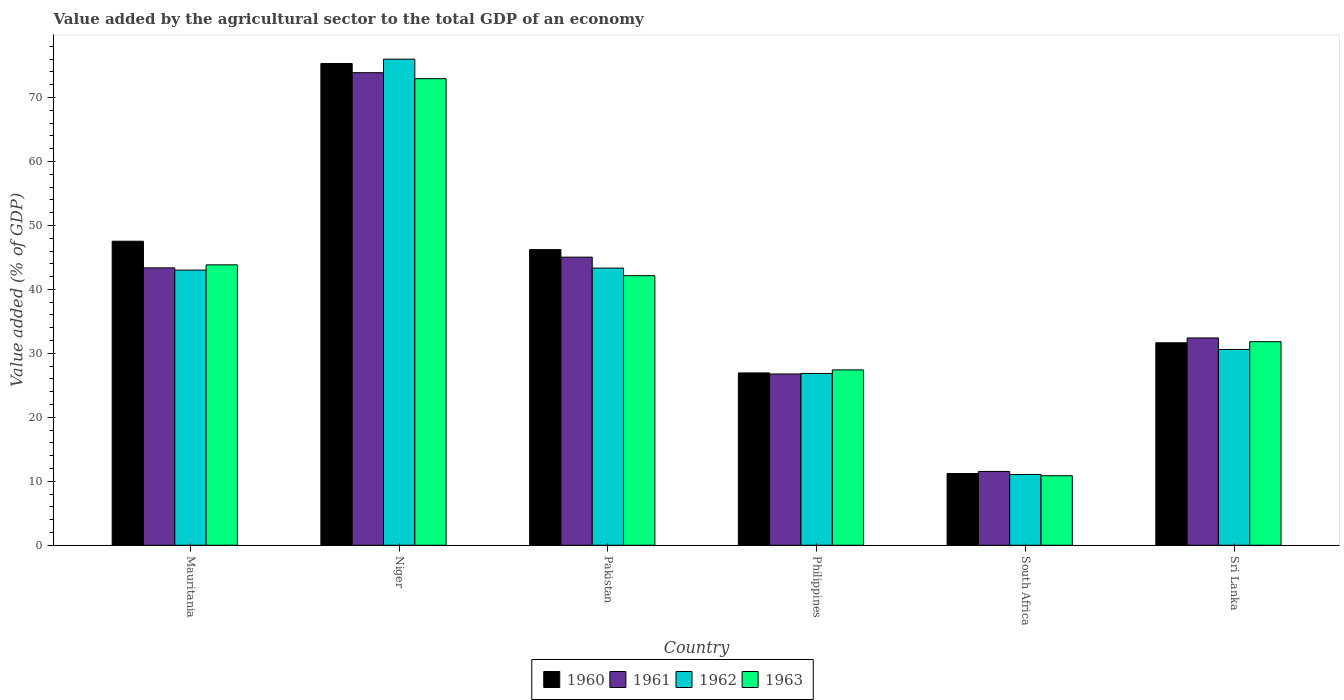Are the number of bars per tick equal to the number of legend labels?
Offer a terse response. Yes. Are the number of bars on each tick of the X-axis equal?
Provide a short and direct response. Yes. How many bars are there on the 3rd tick from the left?
Your answer should be very brief. 4. How many bars are there on the 1st tick from the right?
Your answer should be compact. 4. What is the label of the 5th group of bars from the left?
Offer a terse response. South Africa. In how many cases, is the number of bars for a given country not equal to the number of legend labels?
Keep it short and to the point. 0. What is the value added by the agricultural sector to the total GDP in 1963 in Pakistan?
Provide a short and direct response. 42.15. Across all countries, what is the maximum value added by the agricultural sector to the total GDP in 1962?
Make the answer very short. 76. Across all countries, what is the minimum value added by the agricultural sector to the total GDP in 1961?
Your answer should be compact. 11.54. In which country was the value added by the agricultural sector to the total GDP in 1961 maximum?
Provide a short and direct response. Niger. In which country was the value added by the agricultural sector to the total GDP in 1960 minimum?
Make the answer very short. South Africa. What is the total value added by the agricultural sector to the total GDP in 1960 in the graph?
Keep it short and to the point. 238.89. What is the difference between the value added by the agricultural sector to the total GDP in 1963 in Mauritania and that in Pakistan?
Keep it short and to the point. 1.69. What is the difference between the value added by the agricultural sector to the total GDP in 1960 in Mauritania and the value added by the agricultural sector to the total GDP in 1961 in Pakistan?
Your answer should be compact. 2.49. What is the average value added by the agricultural sector to the total GDP in 1961 per country?
Your answer should be very brief. 38.84. What is the difference between the value added by the agricultural sector to the total GDP of/in 1961 and value added by the agricultural sector to the total GDP of/in 1962 in Philippines?
Make the answer very short. -0.08. What is the ratio of the value added by the agricultural sector to the total GDP in 1962 in Mauritania to that in Sri Lanka?
Provide a short and direct response. 1.41. Is the difference between the value added by the agricultural sector to the total GDP in 1961 in Pakistan and Sri Lanka greater than the difference between the value added by the agricultural sector to the total GDP in 1962 in Pakistan and Sri Lanka?
Offer a very short reply. No. What is the difference between the highest and the second highest value added by the agricultural sector to the total GDP in 1961?
Your answer should be compact. 30.52. What is the difference between the highest and the lowest value added by the agricultural sector to the total GDP in 1961?
Offer a terse response. 62.35. Is it the case that in every country, the sum of the value added by the agricultural sector to the total GDP in 1963 and value added by the agricultural sector to the total GDP in 1962 is greater than the sum of value added by the agricultural sector to the total GDP in 1960 and value added by the agricultural sector to the total GDP in 1961?
Make the answer very short. No. What does the 2nd bar from the left in Philippines represents?
Offer a terse response. 1961. What does the 3rd bar from the right in Sri Lanka represents?
Ensure brevity in your answer.  1961. Is it the case that in every country, the sum of the value added by the agricultural sector to the total GDP in 1963 and value added by the agricultural sector to the total GDP in 1962 is greater than the value added by the agricultural sector to the total GDP in 1960?
Your response must be concise. Yes. Are all the bars in the graph horizontal?
Your answer should be compact. No. How many countries are there in the graph?
Offer a very short reply. 6. Does the graph contain any zero values?
Your answer should be compact. No. Does the graph contain grids?
Your response must be concise. No. Where does the legend appear in the graph?
Make the answer very short. Bottom center. How many legend labels are there?
Offer a terse response. 4. What is the title of the graph?
Your response must be concise. Value added by the agricultural sector to the total GDP of an economy. Does "1979" appear as one of the legend labels in the graph?
Offer a terse response. No. What is the label or title of the X-axis?
Your answer should be very brief. Country. What is the label or title of the Y-axis?
Provide a short and direct response. Value added (% of GDP). What is the Value added (% of GDP) in 1960 in Mauritania?
Your response must be concise. 47.53. What is the Value added (% of GDP) in 1961 in Mauritania?
Provide a succinct answer. 43.37. What is the Value added (% of GDP) in 1962 in Mauritania?
Keep it short and to the point. 43.02. What is the Value added (% of GDP) in 1963 in Mauritania?
Your answer should be compact. 43.84. What is the Value added (% of GDP) of 1960 in Niger?
Ensure brevity in your answer.  75.32. What is the Value added (% of GDP) of 1961 in Niger?
Make the answer very short. 73.89. What is the Value added (% of GDP) of 1962 in Niger?
Ensure brevity in your answer.  76. What is the Value added (% of GDP) in 1963 in Niger?
Keep it short and to the point. 72.95. What is the Value added (% of GDP) in 1960 in Pakistan?
Your answer should be compact. 46.22. What is the Value added (% of GDP) in 1961 in Pakistan?
Your answer should be compact. 45.04. What is the Value added (% of GDP) in 1962 in Pakistan?
Ensure brevity in your answer.  43.33. What is the Value added (% of GDP) in 1963 in Pakistan?
Offer a terse response. 42.15. What is the Value added (% of GDP) in 1960 in Philippines?
Make the answer very short. 26.94. What is the Value added (% of GDP) of 1961 in Philippines?
Make the answer very short. 26.78. What is the Value added (% of GDP) of 1962 in Philippines?
Provide a short and direct response. 26.86. What is the Value added (% of GDP) of 1963 in Philippines?
Give a very brief answer. 27.41. What is the Value added (% of GDP) of 1960 in South Africa?
Your answer should be compact. 11.21. What is the Value added (% of GDP) in 1961 in South Africa?
Keep it short and to the point. 11.54. What is the Value added (% of GDP) of 1962 in South Africa?
Make the answer very short. 11.06. What is the Value added (% of GDP) in 1963 in South Africa?
Offer a very short reply. 10.87. What is the Value added (% of GDP) in 1960 in Sri Lanka?
Your answer should be very brief. 31.66. What is the Value added (% of GDP) in 1961 in Sri Lanka?
Your response must be concise. 32.41. What is the Value added (% of GDP) of 1962 in Sri Lanka?
Ensure brevity in your answer.  30.61. What is the Value added (% of GDP) of 1963 in Sri Lanka?
Ensure brevity in your answer.  31.83. Across all countries, what is the maximum Value added (% of GDP) in 1960?
Offer a terse response. 75.32. Across all countries, what is the maximum Value added (% of GDP) of 1961?
Offer a terse response. 73.89. Across all countries, what is the maximum Value added (% of GDP) in 1962?
Offer a terse response. 76. Across all countries, what is the maximum Value added (% of GDP) in 1963?
Provide a succinct answer. 72.95. Across all countries, what is the minimum Value added (% of GDP) of 1960?
Provide a short and direct response. 11.21. Across all countries, what is the minimum Value added (% of GDP) in 1961?
Ensure brevity in your answer.  11.54. Across all countries, what is the minimum Value added (% of GDP) in 1962?
Ensure brevity in your answer.  11.06. Across all countries, what is the minimum Value added (% of GDP) in 1963?
Your response must be concise. 10.87. What is the total Value added (% of GDP) of 1960 in the graph?
Provide a succinct answer. 238.89. What is the total Value added (% of GDP) of 1961 in the graph?
Provide a succinct answer. 233.02. What is the total Value added (% of GDP) of 1962 in the graph?
Make the answer very short. 230.88. What is the total Value added (% of GDP) of 1963 in the graph?
Provide a succinct answer. 229.04. What is the difference between the Value added (% of GDP) of 1960 in Mauritania and that in Niger?
Offer a very short reply. -27.79. What is the difference between the Value added (% of GDP) of 1961 in Mauritania and that in Niger?
Provide a short and direct response. -30.52. What is the difference between the Value added (% of GDP) of 1962 in Mauritania and that in Niger?
Provide a short and direct response. -32.98. What is the difference between the Value added (% of GDP) of 1963 in Mauritania and that in Niger?
Make the answer very short. -29.11. What is the difference between the Value added (% of GDP) in 1960 in Mauritania and that in Pakistan?
Keep it short and to the point. 1.31. What is the difference between the Value added (% of GDP) of 1961 in Mauritania and that in Pakistan?
Your response must be concise. -1.68. What is the difference between the Value added (% of GDP) in 1962 in Mauritania and that in Pakistan?
Make the answer very short. -0.31. What is the difference between the Value added (% of GDP) in 1963 in Mauritania and that in Pakistan?
Offer a very short reply. 1.69. What is the difference between the Value added (% of GDP) of 1960 in Mauritania and that in Philippines?
Provide a succinct answer. 20.59. What is the difference between the Value added (% of GDP) of 1961 in Mauritania and that in Philippines?
Provide a succinct answer. 16.59. What is the difference between the Value added (% of GDP) in 1962 in Mauritania and that in Philippines?
Your answer should be compact. 16.16. What is the difference between the Value added (% of GDP) in 1963 in Mauritania and that in Philippines?
Your answer should be very brief. 16.43. What is the difference between the Value added (% of GDP) of 1960 in Mauritania and that in South Africa?
Make the answer very short. 36.32. What is the difference between the Value added (% of GDP) of 1961 in Mauritania and that in South Africa?
Your answer should be very brief. 31.83. What is the difference between the Value added (% of GDP) in 1962 in Mauritania and that in South Africa?
Provide a short and direct response. 31.96. What is the difference between the Value added (% of GDP) in 1963 in Mauritania and that in South Africa?
Keep it short and to the point. 32.97. What is the difference between the Value added (% of GDP) of 1960 in Mauritania and that in Sri Lanka?
Provide a succinct answer. 15.88. What is the difference between the Value added (% of GDP) of 1961 in Mauritania and that in Sri Lanka?
Offer a terse response. 10.96. What is the difference between the Value added (% of GDP) in 1962 in Mauritania and that in Sri Lanka?
Give a very brief answer. 12.4. What is the difference between the Value added (% of GDP) of 1963 in Mauritania and that in Sri Lanka?
Provide a succinct answer. 12.01. What is the difference between the Value added (% of GDP) of 1960 in Niger and that in Pakistan?
Provide a short and direct response. 29.1. What is the difference between the Value added (% of GDP) of 1961 in Niger and that in Pakistan?
Provide a succinct answer. 28.84. What is the difference between the Value added (% of GDP) in 1962 in Niger and that in Pakistan?
Your answer should be compact. 32.66. What is the difference between the Value added (% of GDP) in 1963 in Niger and that in Pakistan?
Your response must be concise. 30.8. What is the difference between the Value added (% of GDP) of 1960 in Niger and that in Philippines?
Your answer should be compact. 48.38. What is the difference between the Value added (% of GDP) of 1961 in Niger and that in Philippines?
Provide a short and direct response. 47.11. What is the difference between the Value added (% of GDP) of 1962 in Niger and that in Philippines?
Your response must be concise. 49.14. What is the difference between the Value added (% of GDP) of 1963 in Niger and that in Philippines?
Your response must be concise. 45.54. What is the difference between the Value added (% of GDP) of 1960 in Niger and that in South Africa?
Offer a terse response. 64.11. What is the difference between the Value added (% of GDP) of 1961 in Niger and that in South Africa?
Your response must be concise. 62.35. What is the difference between the Value added (% of GDP) in 1962 in Niger and that in South Africa?
Your response must be concise. 64.94. What is the difference between the Value added (% of GDP) of 1963 in Niger and that in South Africa?
Give a very brief answer. 62.08. What is the difference between the Value added (% of GDP) in 1960 in Niger and that in Sri Lanka?
Your answer should be compact. 43.67. What is the difference between the Value added (% of GDP) of 1961 in Niger and that in Sri Lanka?
Ensure brevity in your answer.  41.48. What is the difference between the Value added (% of GDP) in 1962 in Niger and that in Sri Lanka?
Your response must be concise. 45.38. What is the difference between the Value added (% of GDP) in 1963 in Niger and that in Sri Lanka?
Offer a terse response. 41.12. What is the difference between the Value added (% of GDP) of 1960 in Pakistan and that in Philippines?
Keep it short and to the point. 19.28. What is the difference between the Value added (% of GDP) of 1961 in Pakistan and that in Philippines?
Your answer should be very brief. 18.27. What is the difference between the Value added (% of GDP) in 1962 in Pakistan and that in Philippines?
Your response must be concise. 16.48. What is the difference between the Value added (% of GDP) of 1963 in Pakistan and that in Philippines?
Your answer should be very brief. 14.73. What is the difference between the Value added (% of GDP) of 1960 in Pakistan and that in South Africa?
Provide a short and direct response. 35.01. What is the difference between the Value added (% of GDP) in 1961 in Pakistan and that in South Africa?
Offer a very short reply. 33.51. What is the difference between the Value added (% of GDP) of 1962 in Pakistan and that in South Africa?
Give a very brief answer. 32.28. What is the difference between the Value added (% of GDP) of 1963 in Pakistan and that in South Africa?
Your answer should be very brief. 31.28. What is the difference between the Value added (% of GDP) in 1960 in Pakistan and that in Sri Lanka?
Provide a succinct answer. 14.56. What is the difference between the Value added (% of GDP) of 1961 in Pakistan and that in Sri Lanka?
Keep it short and to the point. 12.63. What is the difference between the Value added (% of GDP) of 1962 in Pakistan and that in Sri Lanka?
Offer a very short reply. 12.72. What is the difference between the Value added (% of GDP) in 1963 in Pakistan and that in Sri Lanka?
Your answer should be compact. 10.32. What is the difference between the Value added (% of GDP) of 1960 in Philippines and that in South Africa?
Your answer should be very brief. 15.73. What is the difference between the Value added (% of GDP) in 1961 in Philippines and that in South Africa?
Provide a short and direct response. 15.24. What is the difference between the Value added (% of GDP) in 1962 in Philippines and that in South Africa?
Make the answer very short. 15.8. What is the difference between the Value added (% of GDP) of 1963 in Philippines and that in South Africa?
Make the answer very short. 16.54. What is the difference between the Value added (% of GDP) of 1960 in Philippines and that in Sri Lanka?
Your answer should be compact. -4.72. What is the difference between the Value added (% of GDP) of 1961 in Philippines and that in Sri Lanka?
Keep it short and to the point. -5.63. What is the difference between the Value added (% of GDP) of 1962 in Philippines and that in Sri Lanka?
Your answer should be compact. -3.76. What is the difference between the Value added (% of GDP) in 1963 in Philippines and that in Sri Lanka?
Offer a very short reply. -4.41. What is the difference between the Value added (% of GDP) of 1960 in South Africa and that in Sri Lanka?
Your answer should be very brief. -20.45. What is the difference between the Value added (% of GDP) of 1961 in South Africa and that in Sri Lanka?
Provide a short and direct response. -20.87. What is the difference between the Value added (% of GDP) of 1962 in South Africa and that in Sri Lanka?
Your response must be concise. -19.56. What is the difference between the Value added (% of GDP) in 1963 in South Africa and that in Sri Lanka?
Offer a very short reply. -20.96. What is the difference between the Value added (% of GDP) in 1960 in Mauritania and the Value added (% of GDP) in 1961 in Niger?
Offer a terse response. -26.35. What is the difference between the Value added (% of GDP) of 1960 in Mauritania and the Value added (% of GDP) of 1962 in Niger?
Your answer should be very brief. -28.46. What is the difference between the Value added (% of GDP) in 1960 in Mauritania and the Value added (% of GDP) in 1963 in Niger?
Offer a terse response. -25.41. What is the difference between the Value added (% of GDP) of 1961 in Mauritania and the Value added (% of GDP) of 1962 in Niger?
Offer a very short reply. -32.63. What is the difference between the Value added (% of GDP) of 1961 in Mauritania and the Value added (% of GDP) of 1963 in Niger?
Give a very brief answer. -29.58. What is the difference between the Value added (% of GDP) of 1962 in Mauritania and the Value added (% of GDP) of 1963 in Niger?
Give a very brief answer. -29.93. What is the difference between the Value added (% of GDP) of 1960 in Mauritania and the Value added (% of GDP) of 1961 in Pakistan?
Offer a very short reply. 2.49. What is the difference between the Value added (% of GDP) of 1960 in Mauritania and the Value added (% of GDP) of 1962 in Pakistan?
Ensure brevity in your answer.  4.2. What is the difference between the Value added (% of GDP) of 1960 in Mauritania and the Value added (% of GDP) of 1963 in Pakistan?
Make the answer very short. 5.39. What is the difference between the Value added (% of GDP) of 1961 in Mauritania and the Value added (% of GDP) of 1962 in Pakistan?
Provide a short and direct response. 0.03. What is the difference between the Value added (% of GDP) of 1961 in Mauritania and the Value added (% of GDP) of 1963 in Pakistan?
Keep it short and to the point. 1.22. What is the difference between the Value added (% of GDP) of 1962 in Mauritania and the Value added (% of GDP) of 1963 in Pakistan?
Make the answer very short. 0.87. What is the difference between the Value added (% of GDP) in 1960 in Mauritania and the Value added (% of GDP) in 1961 in Philippines?
Your answer should be very brief. 20.76. What is the difference between the Value added (% of GDP) in 1960 in Mauritania and the Value added (% of GDP) in 1962 in Philippines?
Give a very brief answer. 20.68. What is the difference between the Value added (% of GDP) in 1960 in Mauritania and the Value added (% of GDP) in 1963 in Philippines?
Your answer should be compact. 20.12. What is the difference between the Value added (% of GDP) of 1961 in Mauritania and the Value added (% of GDP) of 1962 in Philippines?
Your answer should be compact. 16.51. What is the difference between the Value added (% of GDP) in 1961 in Mauritania and the Value added (% of GDP) in 1963 in Philippines?
Offer a terse response. 15.96. What is the difference between the Value added (% of GDP) in 1962 in Mauritania and the Value added (% of GDP) in 1963 in Philippines?
Give a very brief answer. 15.61. What is the difference between the Value added (% of GDP) in 1960 in Mauritania and the Value added (% of GDP) in 1961 in South Africa?
Give a very brief answer. 36. What is the difference between the Value added (% of GDP) in 1960 in Mauritania and the Value added (% of GDP) in 1962 in South Africa?
Offer a terse response. 36.48. What is the difference between the Value added (% of GDP) of 1960 in Mauritania and the Value added (% of GDP) of 1963 in South Africa?
Provide a short and direct response. 36.67. What is the difference between the Value added (% of GDP) in 1961 in Mauritania and the Value added (% of GDP) in 1962 in South Africa?
Offer a terse response. 32.31. What is the difference between the Value added (% of GDP) of 1961 in Mauritania and the Value added (% of GDP) of 1963 in South Africa?
Ensure brevity in your answer.  32.5. What is the difference between the Value added (% of GDP) of 1962 in Mauritania and the Value added (% of GDP) of 1963 in South Africa?
Your response must be concise. 32.15. What is the difference between the Value added (% of GDP) of 1960 in Mauritania and the Value added (% of GDP) of 1961 in Sri Lanka?
Provide a succinct answer. 15.12. What is the difference between the Value added (% of GDP) in 1960 in Mauritania and the Value added (% of GDP) in 1962 in Sri Lanka?
Provide a succinct answer. 16.92. What is the difference between the Value added (% of GDP) in 1960 in Mauritania and the Value added (% of GDP) in 1963 in Sri Lanka?
Ensure brevity in your answer.  15.71. What is the difference between the Value added (% of GDP) in 1961 in Mauritania and the Value added (% of GDP) in 1962 in Sri Lanka?
Your answer should be very brief. 12.75. What is the difference between the Value added (% of GDP) in 1961 in Mauritania and the Value added (% of GDP) in 1963 in Sri Lanka?
Your answer should be very brief. 11.54. What is the difference between the Value added (% of GDP) of 1962 in Mauritania and the Value added (% of GDP) of 1963 in Sri Lanka?
Offer a terse response. 11.19. What is the difference between the Value added (% of GDP) of 1960 in Niger and the Value added (% of GDP) of 1961 in Pakistan?
Offer a very short reply. 30.28. What is the difference between the Value added (% of GDP) of 1960 in Niger and the Value added (% of GDP) of 1962 in Pakistan?
Make the answer very short. 31.99. What is the difference between the Value added (% of GDP) in 1960 in Niger and the Value added (% of GDP) in 1963 in Pakistan?
Provide a succinct answer. 33.18. What is the difference between the Value added (% of GDP) in 1961 in Niger and the Value added (% of GDP) in 1962 in Pakistan?
Provide a short and direct response. 30.55. What is the difference between the Value added (% of GDP) in 1961 in Niger and the Value added (% of GDP) in 1963 in Pakistan?
Make the answer very short. 31.74. What is the difference between the Value added (% of GDP) in 1962 in Niger and the Value added (% of GDP) in 1963 in Pakistan?
Give a very brief answer. 33.85. What is the difference between the Value added (% of GDP) of 1960 in Niger and the Value added (% of GDP) of 1961 in Philippines?
Ensure brevity in your answer.  48.55. What is the difference between the Value added (% of GDP) in 1960 in Niger and the Value added (% of GDP) in 1962 in Philippines?
Provide a succinct answer. 48.47. What is the difference between the Value added (% of GDP) in 1960 in Niger and the Value added (% of GDP) in 1963 in Philippines?
Provide a short and direct response. 47.91. What is the difference between the Value added (% of GDP) in 1961 in Niger and the Value added (% of GDP) in 1962 in Philippines?
Your response must be concise. 47.03. What is the difference between the Value added (% of GDP) in 1961 in Niger and the Value added (% of GDP) in 1963 in Philippines?
Keep it short and to the point. 46.48. What is the difference between the Value added (% of GDP) of 1962 in Niger and the Value added (% of GDP) of 1963 in Philippines?
Offer a very short reply. 48.59. What is the difference between the Value added (% of GDP) in 1960 in Niger and the Value added (% of GDP) in 1961 in South Africa?
Give a very brief answer. 63.79. What is the difference between the Value added (% of GDP) of 1960 in Niger and the Value added (% of GDP) of 1962 in South Africa?
Make the answer very short. 64.27. What is the difference between the Value added (% of GDP) of 1960 in Niger and the Value added (% of GDP) of 1963 in South Africa?
Ensure brevity in your answer.  64.46. What is the difference between the Value added (% of GDP) in 1961 in Niger and the Value added (% of GDP) in 1962 in South Africa?
Keep it short and to the point. 62.83. What is the difference between the Value added (% of GDP) in 1961 in Niger and the Value added (% of GDP) in 1963 in South Africa?
Offer a very short reply. 63.02. What is the difference between the Value added (% of GDP) of 1962 in Niger and the Value added (% of GDP) of 1963 in South Africa?
Make the answer very short. 65.13. What is the difference between the Value added (% of GDP) of 1960 in Niger and the Value added (% of GDP) of 1961 in Sri Lanka?
Ensure brevity in your answer.  42.91. What is the difference between the Value added (% of GDP) of 1960 in Niger and the Value added (% of GDP) of 1962 in Sri Lanka?
Keep it short and to the point. 44.71. What is the difference between the Value added (% of GDP) of 1960 in Niger and the Value added (% of GDP) of 1963 in Sri Lanka?
Provide a succinct answer. 43.5. What is the difference between the Value added (% of GDP) in 1961 in Niger and the Value added (% of GDP) in 1962 in Sri Lanka?
Provide a succinct answer. 43.27. What is the difference between the Value added (% of GDP) in 1961 in Niger and the Value added (% of GDP) in 1963 in Sri Lanka?
Provide a succinct answer. 42.06. What is the difference between the Value added (% of GDP) of 1962 in Niger and the Value added (% of GDP) of 1963 in Sri Lanka?
Provide a short and direct response. 44.17. What is the difference between the Value added (% of GDP) of 1960 in Pakistan and the Value added (% of GDP) of 1961 in Philippines?
Provide a short and direct response. 19.44. What is the difference between the Value added (% of GDP) of 1960 in Pakistan and the Value added (% of GDP) of 1962 in Philippines?
Keep it short and to the point. 19.36. What is the difference between the Value added (% of GDP) in 1960 in Pakistan and the Value added (% of GDP) in 1963 in Philippines?
Give a very brief answer. 18.81. What is the difference between the Value added (% of GDP) in 1961 in Pakistan and the Value added (% of GDP) in 1962 in Philippines?
Your answer should be compact. 18.19. What is the difference between the Value added (% of GDP) in 1961 in Pakistan and the Value added (% of GDP) in 1963 in Philippines?
Offer a very short reply. 17.63. What is the difference between the Value added (% of GDP) in 1962 in Pakistan and the Value added (% of GDP) in 1963 in Philippines?
Ensure brevity in your answer.  15.92. What is the difference between the Value added (% of GDP) of 1960 in Pakistan and the Value added (% of GDP) of 1961 in South Africa?
Provide a succinct answer. 34.68. What is the difference between the Value added (% of GDP) of 1960 in Pakistan and the Value added (% of GDP) of 1962 in South Africa?
Offer a very short reply. 35.16. What is the difference between the Value added (% of GDP) of 1960 in Pakistan and the Value added (% of GDP) of 1963 in South Africa?
Keep it short and to the point. 35.35. What is the difference between the Value added (% of GDP) in 1961 in Pakistan and the Value added (% of GDP) in 1962 in South Africa?
Give a very brief answer. 33.99. What is the difference between the Value added (% of GDP) of 1961 in Pakistan and the Value added (% of GDP) of 1963 in South Africa?
Your response must be concise. 34.17. What is the difference between the Value added (% of GDP) of 1962 in Pakistan and the Value added (% of GDP) of 1963 in South Africa?
Offer a terse response. 32.46. What is the difference between the Value added (% of GDP) in 1960 in Pakistan and the Value added (% of GDP) in 1961 in Sri Lanka?
Offer a very short reply. 13.81. What is the difference between the Value added (% of GDP) in 1960 in Pakistan and the Value added (% of GDP) in 1962 in Sri Lanka?
Ensure brevity in your answer.  15.61. What is the difference between the Value added (% of GDP) of 1960 in Pakistan and the Value added (% of GDP) of 1963 in Sri Lanka?
Offer a very short reply. 14.39. What is the difference between the Value added (% of GDP) of 1961 in Pakistan and the Value added (% of GDP) of 1962 in Sri Lanka?
Your answer should be compact. 14.43. What is the difference between the Value added (% of GDP) in 1961 in Pakistan and the Value added (% of GDP) in 1963 in Sri Lanka?
Make the answer very short. 13.22. What is the difference between the Value added (% of GDP) in 1962 in Pakistan and the Value added (% of GDP) in 1963 in Sri Lanka?
Offer a very short reply. 11.51. What is the difference between the Value added (% of GDP) in 1960 in Philippines and the Value added (% of GDP) in 1961 in South Africa?
Keep it short and to the point. 15.4. What is the difference between the Value added (% of GDP) in 1960 in Philippines and the Value added (% of GDP) in 1962 in South Africa?
Give a very brief answer. 15.88. What is the difference between the Value added (% of GDP) in 1960 in Philippines and the Value added (% of GDP) in 1963 in South Africa?
Ensure brevity in your answer.  16.07. What is the difference between the Value added (% of GDP) in 1961 in Philippines and the Value added (% of GDP) in 1962 in South Africa?
Your answer should be compact. 15.72. What is the difference between the Value added (% of GDP) of 1961 in Philippines and the Value added (% of GDP) of 1963 in South Africa?
Offer a terse response. 15.91. What is the difference between the Value added (% of GDP) of 1962 in Philippines and the Value added (% of GDP) of 1963 in South Africa?
Make the answer very short. 15.99. What is the difference between the Value added (% of GDP) of 1960 in Philippines and the Value added (% of GDP) of 1961 in Sri Lanka?
Your response must be concise. -5.47. What is the difference between the Value added (% of GDP) of 1960 in Philippines and the Value added (% of GDP) of 1962 in Sri Lanka?
Your answer should be very brief. -3.67. What is the difference between the Value added (% of GDP) in 1960 in Philippines and the Value added (% of GDP) in 1963 in Sri Lanka?
Keep it short and to the point. -4.89. What is the difference between the Value added (% of GDP) in 1961 in Philippines and the Value added (% of GDP) in 1962 in Sri Lanka?
Your response must be concise. -3.84. What is the difference between the Value added (% of GDP) of 1961 in Philippines and the Value added (% of GDP) of 1963 in Sri Lanka?
Offer a terse response. -5.05. What is the difference between the Value added (% of GDP) in 1962 in Philippines and the Value added (% of GDP) in 1963 in Sri Lanka?
Your response must be concise. -4.97. What is the difference between the Value added (% of GDP) of 1960 in South Africa and the Value added (% of GDP) of 1961 in Sri Lanka?
Your answer should be very brief. -21.2. What is the difference between the Value added (% of GDP) of 1960 in South Africa and the Value added (% of GDP) of 1962 in Sri Lanka?
Keep it short and to the point. -19.4. What is the difference between the Value added (% of GDP) in 1960 in South Africa and the Value added (% of GDP) in 1963 in Sri Lanka?
Provide a short and direct response. -20.62. What is the difference between the Value added (% of GDP) in 1961 in South Africa and the Value added (% of GDP) in 1962 in Sri Lanka?
Offer a very short reply. -19.08. What is the difference between the Value added (% of GDP) in 1961 in South Africa and the Value added (% of GDP) in 1963 in Sri Lanka?
Your answer should be compact. -20.29. What is the difference between the Value added (% of GDP) in 1962 in South Africa and the Value added (% of GDP) in 1963 in Sri Lanka?
Give a very brief answer. -20.77. What is the average Value added (% of GDP) of 1960 per country?
Give a very brief answer. 39.81. What is the average Value added (% of GDP) in 1961 per country?
Provide a succinct answer. 38.84. What is the average Value added (% of GDP) of 1962 per country?
Make the answer very short. 38.48. What is the average Value added (% of GDP) of 1963 per country?
Provide a succinct answer. 38.17. What is the difference between the Value added (% of GDP) of 1960 and Value added (% of GDP) of 1961 in Mauritania?
Give a very brief answer. 4.17. What is the difference between the Value added (% of GDP) in 1960 and Value added (% of GDP) in 1962 in Mauritania?
Provide a succinct answer. 4.52. What is the difference between the Value added (% of GDP) in 1960 and Value added (% of GDP) in 1963 in Mauritania?
Offer a very short reply. 3.69. What is the difference between the Value added (% of GDP) of 1961 and Value added (% of GDP) of 1962 in Mauritania?
Provide a short and direct response. 0.35. What is the difference between the Value added (% of GDP) of 1961 and Value added (% of GDP) of 1963 in Mauritania?
Keep it short and to the point. -0.47. What is the difference between the Value added (% of GDP) in 1962 and Value added (% of GDP) in 1963 in Mauritania?
Make the answer very short. -0.82. What is the difference between the Value added (% of GDP) of 1960 and Value added (% of GDP) of 1961 in Niger?
Your answer should be compact. 1.44. What is the difference between the Value added (% of GDP) of 1960 and Value added (% of GDP) of 1962 in Niger?
Provide a succinct answer. -0.67. What is the difference between the Value added (% of GDP) in 1960 and Value added (% of GDP) in 1963 in Niger?
Your response must be concise. 2.38. What is the difference between the Value added (% of GDP) in 1961 and Value added (% of GDP) in 1962 in Niger?
Give a very brief answer. -2.11. What is the difference between the Value added (% of GDP) of 1961 and Value added (% of GDP) of 1963 in Niger?
Offer a terse response. 0.94. What is the difference between the Value added (% of GDP) of 1962 and Value added (% of GDP) of 1963 in Niger?
Your answer should be very brief. 3.05. What is the difference between the Value added (% of GDP) of 1960 and Value added (% of GDP) of 1961 in Pakistan?
Your answer should be very brief. 1.18. What is the difference between the Value added (% of GDP) of 1960 and Value added (% of GDP) of 1962 in Pakistan?
Offer a terse response. 2.89. What is the difference between the Value added (% of GDP) of 1960 and Value added (% of GDP) of 1963 in Pakistan?
Your answer should be compact. 4.07. What is the difference between the Value added (% of GDP) in 1961 and Value added (% of GDP) in 1962 in Pakistan?
Provide a short and direct response. 1.71. What is the difference between the Value added (% of GDP) in 1961 and Value added (% of GDP) in 1963 in Pakistan?
Provide a succinct answer. 2.9. What is the difference between the Value added (% of GDP) in 1962 and Value added (% of GDP) in 1963 in Pakistan?
Your answer should be very brief. 1.19. What is the difference between the Value added (% of GDP) in 1960 and Value added (% of GDP) in 1961 in Philippines?
Your answer should be compact. 0.16. What is the difference between the Value added (% of GDP) in 1960 and Value added (% of GDP) in 1962 in Philippines?
Offer a very short reply. 0.08. What is the difference between the Value added (% of GDP) of 1960 and Value added (% of GDP) of 1963 in Philippines?
Ensure brevity in your answer.  -0.47. What is the difference between the Value added (% of GDP) of 1961 and Value added (% of GDP) of 1962 in Philippines?
Offer a very short reply. -0.08. What is the difference between the Value added (% of GDP) of 1961 and Value added (% of GDP) of 1963 in Philippines?
Offer a very short reply. -0.64. What is the difference between the Value added (% of GDP) of 1962 and Value added (% of GDP) of 1963 in Philippines?
Offer a very short reply. -0.55. What is the difference between the Value added (% of GDP) of 1960 and Value added (% of GDP) of 1961 in South Africa?
Offer a very short reply. -0.33. What is the difference between the Value added (% of GDP) of 1960 and Value added (% of GDP) of 1962 in South Africa?
Your answer should be compact. 0.15. What is the difference between the Value added (% of GDP) of 1960 and Value added (% of GDP) of 1963 in South Africa?
Keep it short and to the point. 0.34. What is the difference between the Value added (% of GDP) in 1961 and Value added (% of GDP) in 1962 in South Africa?
Provide a short and direct response. 0.48. What is the difference between the Value added (% of GDP) in 1961 and Value added (% of GDP) in 1963 in South Africa?
Offer a very short reply. 0.67. What is the difference between the Value added (% of GDP) in 1962 and Value added (% of GDP) in 1963 in South Africa?
Provide a short and direct response. 0.19. What is the difference between the Value added (% of GDP) of 1960 and Value added (% of GDP) of 1961 in Sri Lanka?
Provide a short and direct response. -0.76. What is the difference between the Value added (% of GDP) of 1960 and Value added (% of GDP) of 1962 in Sri Lanka?
Your answer should be very brief. 1.04. What is the difference between the Value added (% of GDP) in 1960 and Value added (% of GDP) in 1963 in Sri Lanka?
Ensure brevity in your answer.  -0.17. What is the difference between the Value added (% of GDP) of 1961 and Value added (% of GDP) of 1962 in Sri Lanka?
Your response must be concise. 1.8. What is the difference between the Value added (% of GDP) in 1961 and Value added (% of GDP) in 1963 in Sri Lanka?
Your answer should be very brief. 0.59. What is the difference between the Value added (% of GDP) of 1962 and Value added (% of GDP) of 1963 in Sri Lanka?
Your answer should be very brief. -1.21. What is the ratio of the Value added (% of GDP) of 1960 in Mauritania to that in Niger?
Offer a very short reply. 0.63. What is the ratio of the Value added (% of GDP) in 1961 in Mauritania to that in Niger?
Your answer should be compact. 0.59. What is the ratio of the Value added (% of GDP) in 1962 in Mauritania to that in Niger?
Your answer should be very brief. 0.57. What is the ratio of the Value added (% of GDP) of 1963 in Mauritania to that in Niger?
Make the answer very short. 0.6. What is the ratio of the Value added (% of GDP) of 1960 in Mauritania to that in Pakistan?
Offer a very short reply. 1.03. What is the ratio of the Value added (% of GDP) of 1961 in Mauritania to that in Pakistan?
Keep it short and to the point. 0.96. What is the ratio of the Value added (% of GDP) in 1962 in Mauritania to that in Pakistan?
Provide a short and direct response. 0.99. What is the ratio of the Value added (% of GDP) in 1963 in Mauritania to that in Pakistan?
Keep it short and to the point. 1.04. What is the ratio of the Value added (% of GDP) in 1960 in Mauritania to that in Philippines?
Give a very brief answer. 1.76. What is the ratio of the Value added (% of GDP) in 1961 in Mauritania to that in Philippines?
Give a very brief answer. 1.62. What is the ratio of the Value added (% of GDP) in 1962 in Mauritania to that in Philippines?
Offer a very short reply. 1.6. What is the ratio of the Value added (% of GDP) in 1963 in Mauritania to that in Philippines?
Your answer should be very brief. 1.6. What is the ratio of the Value added (% of GDP) in 1960 in Mauritania to that in South Africa?
Make the answer very short. 4.24. What is the ratio of the Value added (% of GDP) of 1961 in Mauritania to that in South Africa?
Give a very brief answer. 3.76. What is the ratio of the Value added (% of GDP) in 1962 in Mauritania to that in South Africa?
Make the answer very short. 3.89. What is the ratio of the Value added (% of GDP) in 1963 in Mauritania to that in South Africa?
Provide a succinct answer. 4.03. What is the ratio of the Value added (% of GDP) in 1960 in Mauritania to that in Sri Lanka?
Offer a very short reply. 1.5. What is the ratio of the Value added (% of GDP) in 1961 in Mauritania to that in Sri Lanka?
Provide a short and direct response. 1.34. What is the ratio of the Value added (% of GDP) in 1962 in Mauritania to that in Sri Lanka?
Your response must be concise. 1.41. What is the ratio of the Value added (% of GDP) in 1963 in Mauritania to that in Sri Lanka?
Ensure brevity in your answer.  1.38. What is the ratio of the Value added (% of GDP) of 1960 in Niger to that in Pakistan?
Offer a terse response. 1.63. What is the ratio of the Value added (% of GDP) of 1961 in Niger to that in Pakistan?
Your answer should be compact. 1.64. What is the ratio of the Value added (% of GDP) in 1962 in Niger to that in Pakistan?
Offer a terse response. 1.75. What is the ratio of the Value added (% of GDP) in 1963 in Niger to that in Pakistan?
Offer a terse response. 1.73. What is the ratio of the Value added (% of GDP) in 1960 in Niger to that in Philippines?
Provide a short and direct response. 2.8. What is the ratio of the Value added (% of GDP) in 1961 in Niger to that in Philippines?
Provide a succinct answer. 2.76. What is the ratio of the Value added (% of GDP) in 1962 in Niger to that in Philippines?
Offer a very short reply. 2.83. What is the ratio of the Value added (% of GDP) in 1963 in Niger to that in Philippines?
Your response must be concise. 2.66. What is the ratio of the Value added (% of GDP) in 1960 in Niger to that in South Africa?
Make the answer very short. 6.72. What is the ratio of the Value added (% of GDP) in 1961 in Niger to that in South Africa?
Your answer should be compact. 6.4. What is the ratio of the Value added (% of GDP) of 1962 in Niger to that in South Africa?
Give a very brief answer. 6.87. What is the ratio of the Value added (% of GDP) of 1963 in Niger to that in South Africa?
Make the answer very short. 6.71. What is the ratio of the Value added (% of GDP) of 1960 in Niger to that in Sri Lanka?
Give a very brief answer. 2.38. What is the ratio of the Value added (% of GDP) of 1961 in Niger to that in Sri Lanka?
Your response must be concise. 2.28. What is the ratio of the Value added (% of GDP) of 1962 in Niger to that in Sri Lanka?
Provide a short and direct response. 2.48. What is the ratio of the Value added (% of GDP) in 1963 in Niger to that in Sri Lanka?
Ensure brevity in your answer.  2.29. What is the ratio of the Value added (% of GDP) of 1960 in Pakistan to that in Philippines?
Provide a short and direct response. 1.72. What is the ratio of the Value added (% of GDP) in 1961 in Pakistan to that in Philippines?
Offer a very short reply. 1.68. What is the ratio of the Value added (% of GDP) in 1962 in Pakistan to that in Philippines?
Make the answer very short. 1.61. What is the ratio of the Value added (% of GDP) in 1963 in Pakistan to that in Philippines?
Ensure brevity in your answer.  1.54. What is the ratio of the Value added (% of GDP) of 1960 in Pakistan to that in South Africa?
Offer a very short reply. 4.12. What is the ratio of the Value added (% of GDP) of 1961 in Pakistan to that in South Africa?
Your answer should be very brief. 3.9. What is the ratio of the Value added (% of GDP) of 1962 in Pakistan to that in South Africa?
Keep it short and to the point. 3.92. What is the ratio of the Value added (% of GDP) of 1963 in Pakistan to that in South Africa?
Your answer should be very brief. 3.88. What is the ratio of the Value added (% of GDP) in 1960 in Pakistan to that in Sri Lanka?
Keep it short and to the point. 1.46. What is the ratio of the Value added (% of GDP) of 1961 in Pakistan to that in Sri Lanka?
Make the answer very short. 1.39. What is the ratio of the Value added (% of GDP) of 1962 in Pakistan to that in Sri Lanka?
Provide a short and direct response. 1.42. What is the ratio of the Value added (% of GDP) in 1963 in Pakistan to that in Sri Lanka?
Offer a terse response. 1.32. What is the ratio of the Value added (% of GDP) of 1960 in Philippines to that in South Africa?
Offer a terse response. 2.4. What is the ratio of the Value added (% of GDP) of 1961 in Philippines to that in South Africa?
Give a very brief answer. 2.32. What is the ratio of the Value added (% of GDP) in 1962 in Philippines to that in South Africa?
Provide a succinct answer. 2.43. What is the ratio of the Value added (% of GDP) of 1963 in Philippines to that in South Africa?
Your answer should be compact. 2.52. What is the ratio of the Value added (% of GDP) in 1960 in Philippines to that in Sri Lanka?
Provide a succinct answer. 0.85. What is the ratio of the Value added (% of GDP) in 1961 in Philippines to that in Sri Lanka?
Offer a very short reply. 0.83. What is the ratio of the Value added (% of GDP) in 1962 in Philippines to that in Sri Lanka?
Offer a very short reply. 0.88. What is the ratio of the Value added (% of GDP) of 1963 in Philippines to that in Sri Lanka?
Provide a succinct answer. 0.86. What is the ratio of the Value added (% of GDP) of 1960 in South Africa to that in Sri Lanka?
Your response must be concise. 0.35. What is the ratio of the Value added (% of GDP) in 1961 in South Africa to that in Sri Lanka?
Your response must be concise. 0.36. What is the ratio of the Value added (% of GDP) in 1962 in South Africa to that in Sri Lanka?
Provide a succinct answer. 0.36. What is the ratio of the Value added (% of GDP) of 1963 in South Africa to that in Sri Lanka?
Ensure brevity in your answer.  0.34. What is the difference between the highest and the second highest Value added (% of GDP) in 1960?
Ensure brevity in your answer.  27.79. What is the difference between the highest and the second highest Value added (% of GDP) in 1961?
Your answer should be very brief. 28.84. What is the difference between the highest and the second highest Value added (% of GDP) of 1962?
Your answer should be compact. 32.66. What is the difference between the highest and the second highest Value added (% of GDP) in 1963?
Offer a terse response. 29.11. What is the difference between the highest and the lowest Value added (% of GDP) in 1960?
Keep it short and to the point. 64.11. What is the difference between the highest and the lowest Value added (% of GDP) in 1961?
Ensure brevity in your answer.  62.35. What is the difference between the highest and the lowest Value added (% of GDP) of 1962?
Your response must be concise. 64.94. What is the difference between the highest and the lowest Value added (% of GDP) in 1963?
Your response must be concise. 62.08. 